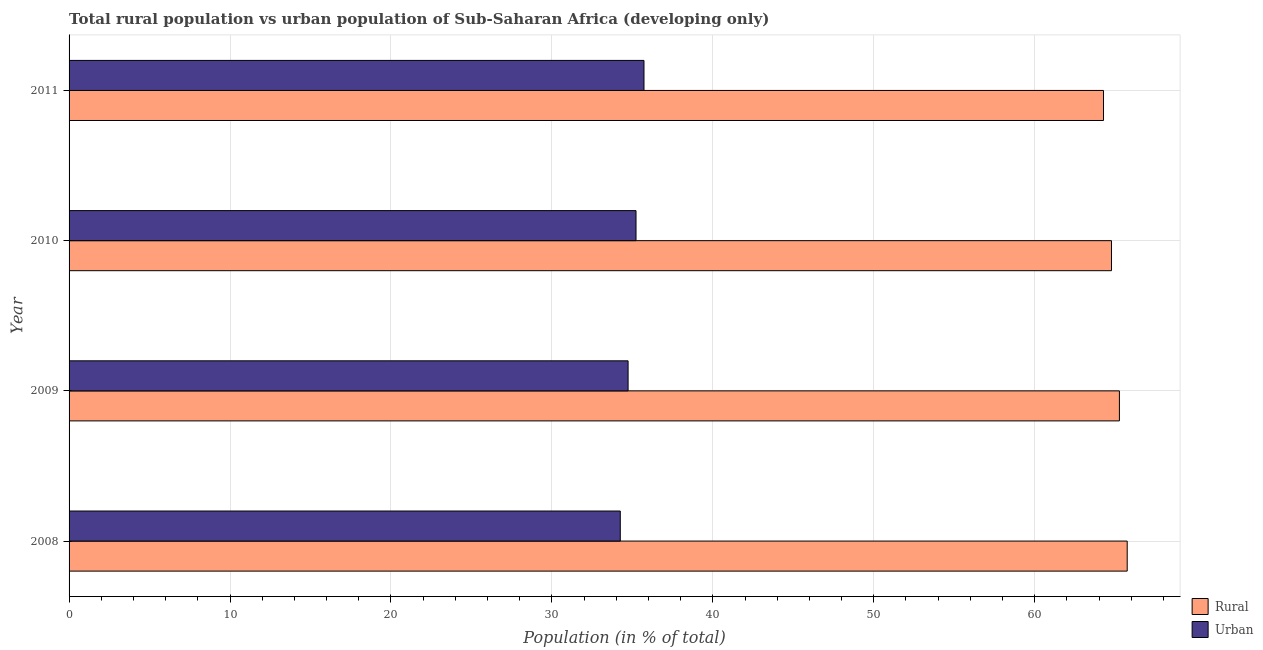How many groups of bars are there?
Make the answer very short. 4. Are the number of bars per tick equal to the number of legend labels?
Your answer should be very brief. Yes. How many bars are there on the 4th tick from the top?
Keep it short and to the point. 2. What is the rural population in 2008?
Provide a short and direct response. 65.75. Across all years, what is the maximum rural population?
Keep it short and to the point. 65.75. Across all years, what is the minimum rural population?
Your answer should be compact. 64.28. In which year was the urban population maximum?
Provide a short and direct response. 2011. In which year was the rural population minimum?
Provide a succinct answer. 2011. What is the total rural population in the graph?
Ensure brevity in your answer.  260.06. What is the difference between the urban population in 2009 and that in 2010?
Offer a very short reply. -0.49. What is the difference between the rural population in 2008 and the urban population in 2010?
Offer a very short reply. 30.52. What is the average rural population per year?
Give a very brief answer. 65.02. In the year 2011, what is the difference between the rural population and urban population?
Your response must be concise. 28.55. Is the urban population in 2008 less than that in 2011?
Make the answer very short. Yes. Is the difference between the rural population in 2008 and 2011 greater than the difference between the urban population in 2008 and 2011?
Keep it short and to the point. Yes. What is the difference between the highest and the second highest urban population?
Ensure brevity in your answer.  0.5. What is the difference between the highest and the lowest urban population?
Your answer should be compact. 1.47. In how many years, is the rural population greater than the average rural population taken over all years?
Offer a terse response. 2. Is the sum of the rural population in 2008 and 2011 greater than the maximum urban population across all years?
Provide a succinct answer. Yes. What does the 2nd bar from the top in 2010 represents?
Give a very brief answer. Rural. What does the 2nd bar from the bottom in 2008 represents?
Give a very brief answer. Urban. Are all the bars in the graph horizontal?
Your response must be concise. Yes. Does the graph contain grids?
Your answer should be compact. Yes. Where does the legend appear in the graph?
Provide a succinct answer. Bottom right. How many legend labels are there?
Keep it short and to the point. 2. How are the legend labels stacked?
Keep it short and to the point. Vertical. What is the title of the graph?
Offer a terse response. Total rural population vs urban population of Sub-Saharan Africa (developing only). Does "Domestic liabilities" appear as one of the legend labels in the graph?
Provide a short and direct response. No. What is the label or title of the X-axis?
Ensure brevity in your answer.  Population (in % of total). What is the Population (in % of total) of Rural in 2008?
Give a very brief answer. 65.75. What is the Population (in % of total) of Urban in 2008?
Make the answer very short. 34.25. What is the Population (in % of total) of Rural in 2009?
Keep it short and to the point. 65.26. What is the Population (in % of total) in Urban in 2009?
Provide a short and direct response. 34.74. What is the Population (in % of total) in Rural in 2010?
Provide a short and direct response. 64.77. What is the Population (in % of total) of Urban in 2010?
Offer a very short reply. 35.23. What is the Population (in % of total) in Rural in 2011?
Make the answer very short. 64.28. What is the Population (in % of total) in Urban in 2011?
Offer a very short reply. 35.72. Across all years, what is the maximum Population (in % of total) in Rural?
Provide a succinct answer. 65.75. Across all years, what is the maximum Population (in % of total) in Urban?
Provide a succinct answer. 35.72. Across all years, what is the minimum Population (in % of total) in Rural?
Provide a short and direct response. 64.28. Across all years, what is the minimum Population (in % of total) of Urban?
Keep it short and to the point. 34.25. What is the total Population (in % of total) in Rural in the graph?
Provide a short and direct response. 260.06. What is the total Population (in % of total) in Urban in the graph?
Make the answer very short. 139.94. What is the difference between the Population (in % of total) in Rural in 2008 and that in 2009?
Make the answer very short. 0.48. What is the difference between the Population (in % of total) in Urban in 2008 and that in 2009?
Ensure brevity in your answer.  -0.48. What is the difference between the Population (in % of total) of Rural in 2008 and that in 2010?
Your answer should be very brief. 0.98. What is the difference between the Population (in % of total) of Urban in 2008 and that in 2010?
Provide a short and direct response. -0.98. What is the difference between the Population (in % of total) in Rural in 2008 and that in 2011?
Provide a short and direct response. 1.47. What is the difference between the Population (in % of total) of Urban in 2008 and that in 2011?
Offer a terse response. -1.47. What is the difference between the Population (in % of total) of Rural in 2009 and that in 2010?
Make the answer very short. 0.49. What is the difference between the Population (in % of total) in Urban in 2009 and that in 2010?
Ensure brevity in your answer.  -0.49. What is the difference between the Population (in % of total) in Rural in 2009 and that in 2011?
Provide a succinct answer. 0.99. What is the difference between the Population (in % of total) in Urban in 2009 and that in 2011?
Ensure brevity in your answer.  -0.99. What is the difference between the Population (in % of total) of Rural in 2010 and that in 2011?
Your answer should be compact. 0.5. What is the difference between the Population (in % of total) of Urban in 2010 and that in 2011?
Offer a very short reply. -0.5. What is the difference between the Population (in % of total) of Rural in 2008 and the Population (in % of total) of Urban in 2009?
Provide a short and direct response. 31.01. What is the difference between the Population (in % of total) in Rural in 2008 and the Population (in % of total) in Urban in 2010?
Provide a short and direct response. 30.52. What is the difference between the Population (in % of total) of Rural in 2008 and the Population (in % of total) of Urban in 2011?
Offer a terse response. 30.03. What is the difference between the Population (in % of total) of Rural in 2009 and the Population (in % of total) of Urban in 2010?
Make the answer very short. 30.04. What is the difference between the Population (in % of total) of Rural in 2009 and the Population (in % of total) of Urban in 2011?
Keep it short and to the point. 29.54. What is the difference between the Population (in % of total) in Rural in 2010 and the Population (in % of total) in Urban in 2011?
Offer a terse response. 29.05. What is the average Population (in % of total) of Rural per year?
Give a very brief answer. 65.02. What is the average Population (in % of total) of Urban per year?
Make the answer very short. 34.98. In the year 2008, what is the difference between the Population (in % of total) of Rural and Population (in % of total) of Urban?
Make the answer very short. 31.5. In the year 2009, what is the difference between the Population (in % of total) of Rural and Population (in % of total) of Urban?
Your answer should be very brief. 30.53. In the year 2010, what is the difference between the Population (in % of total) in Rural and Population (in % of total) in Urban?
Your response must be concise. 29.54. In the year 2011, what is the difference between the Population (in % of total) in Rural and Population (in % of total) in Urban?
Offer a very short reply. 28.55. What is the ratio of the Population (in % of total) in Rural in 2008 to that in 2009?
Your answer should be very brief. 1.01. What is the ratio of the Population (in % of total) of Rural in 2008 to that in 2010?
Provide a short and direct response. 1.02. What is the ratio of the Population (in % of total) in Urban in 2008 to that in 2010?
Provide a succinct answer. 0.97. What is the ratio of the Population (in % of total) of Rural in 2008 to that in 2011?
Give a very brief answer. 1.02. What is the ratio of the Population (in % of total) in Urban in 2008 to that in 2011?
Provide a short and direct response. 0.96. What is the ratio of the Population (in % of total) of Rural in 2009 to that in 2010?
Provide a short and direct response. 1.01. What is the ratio of the Population (in % of total) in Rural in 2009 to that in 2011?
Give a very brief answer. 1.02. What is the ratio of the Population (in % of total) in Urban in 2009 to that in 2011?
Provide a short and direct response. 0.97. What is the ratio of the Population (in % of total) of Rural in 2010 to that in 2011?
Your answer should be very brief. 1.01. What is the ratio of the Population (in % of total) in Urban in 2010 to that in 2011?
Offer a very short reply. 0.99. What is the difference between the highest and the second highest Population (in % of total) in Rural?
Provide a short and direct response. 0.48. What is the difference between the highest and the second highest Population (in % of total) in Urban?
Your answer should be very brief. 0.5. What is the difference between the highest and the lowest Population (in % of total) of Rural?
Give a very brief answer. 1.47. What is the difference between the highest and the lowest Population (in % of total) of Urban?
Make the answer very short. 1.47. 